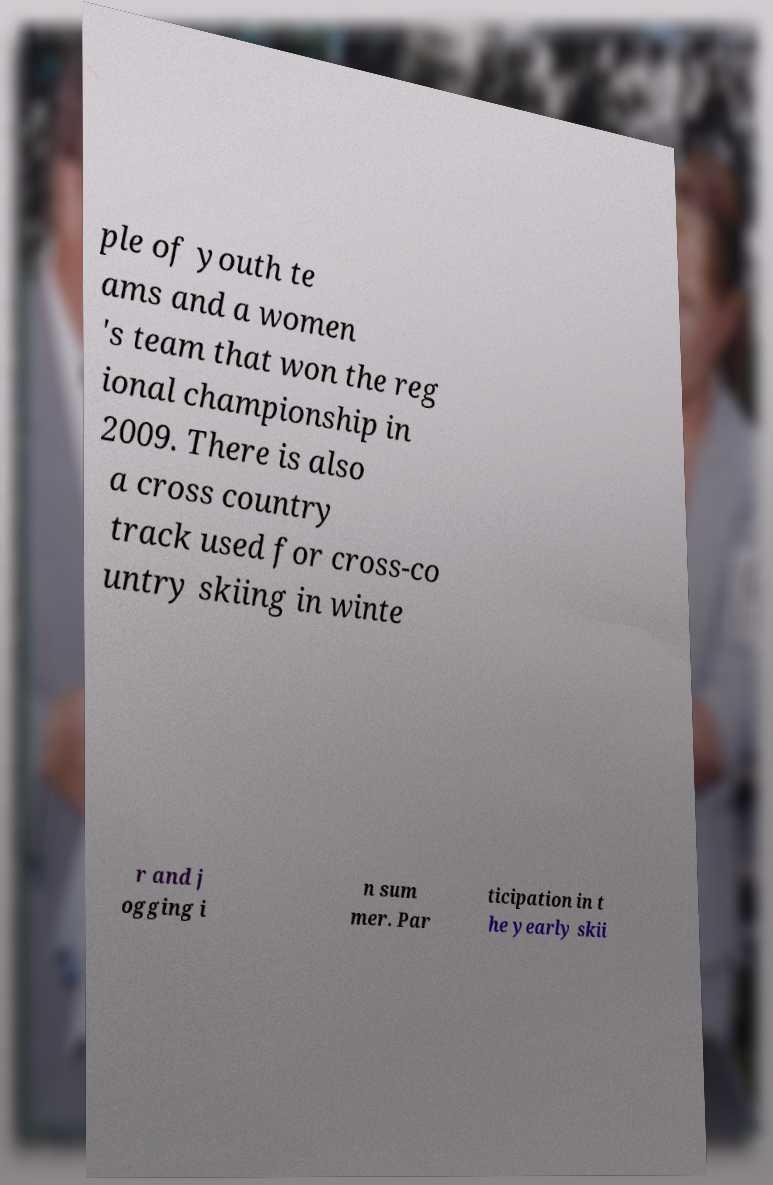What messages or text are displayed in this image? I need them in a readable, typed format. ple of youth te ams and a women 's team that won the reg ional championship in 2009. There is also a cross country track used for cross-co untry skiing in winte r and j ogging i n sum mer. Par ticipation in t he yearly skii 